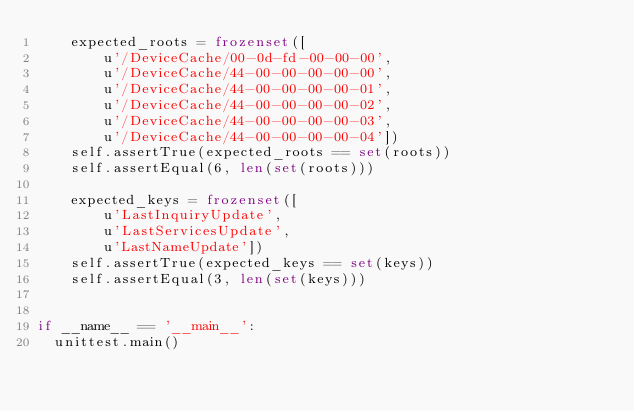<code> <loc_0><loc_0><loc_500><loc_500><_Python_>    expected_roots = frozenset([
        u'/DeviceCache/00-0d-fd-00-00-00',
        u'/DeviceCache/44-00-00-00-00-00',
        u'/DeviceCache/44-00-00-00-00-01',
        u'/DeviceCache/44-00-00-00-00-02',
        u'/DeviceCache/44-00-00-00-00-03',
        u'/DeviceCache/44-00-00-00-00-04'])
    self.assertTrue(expected_roots == set(roots))
    self.assertEqual(6, len(set(roots)))

    expected_keys = frozenset([
        u'LastInquiryUpdate',
        u'LastServicesUpdate',
        u'LastNameUpdate'])
    self.assertTrue(expected_keys == set(keys))
    self.assertEqual(3, len(set(keys)))


if __name__ == '__main__':
  unittest.main()
</code> 